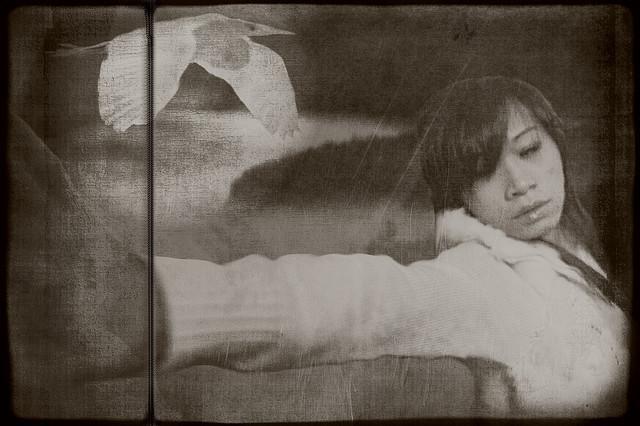How many birds are there?
Give a very brief answer. 1. 